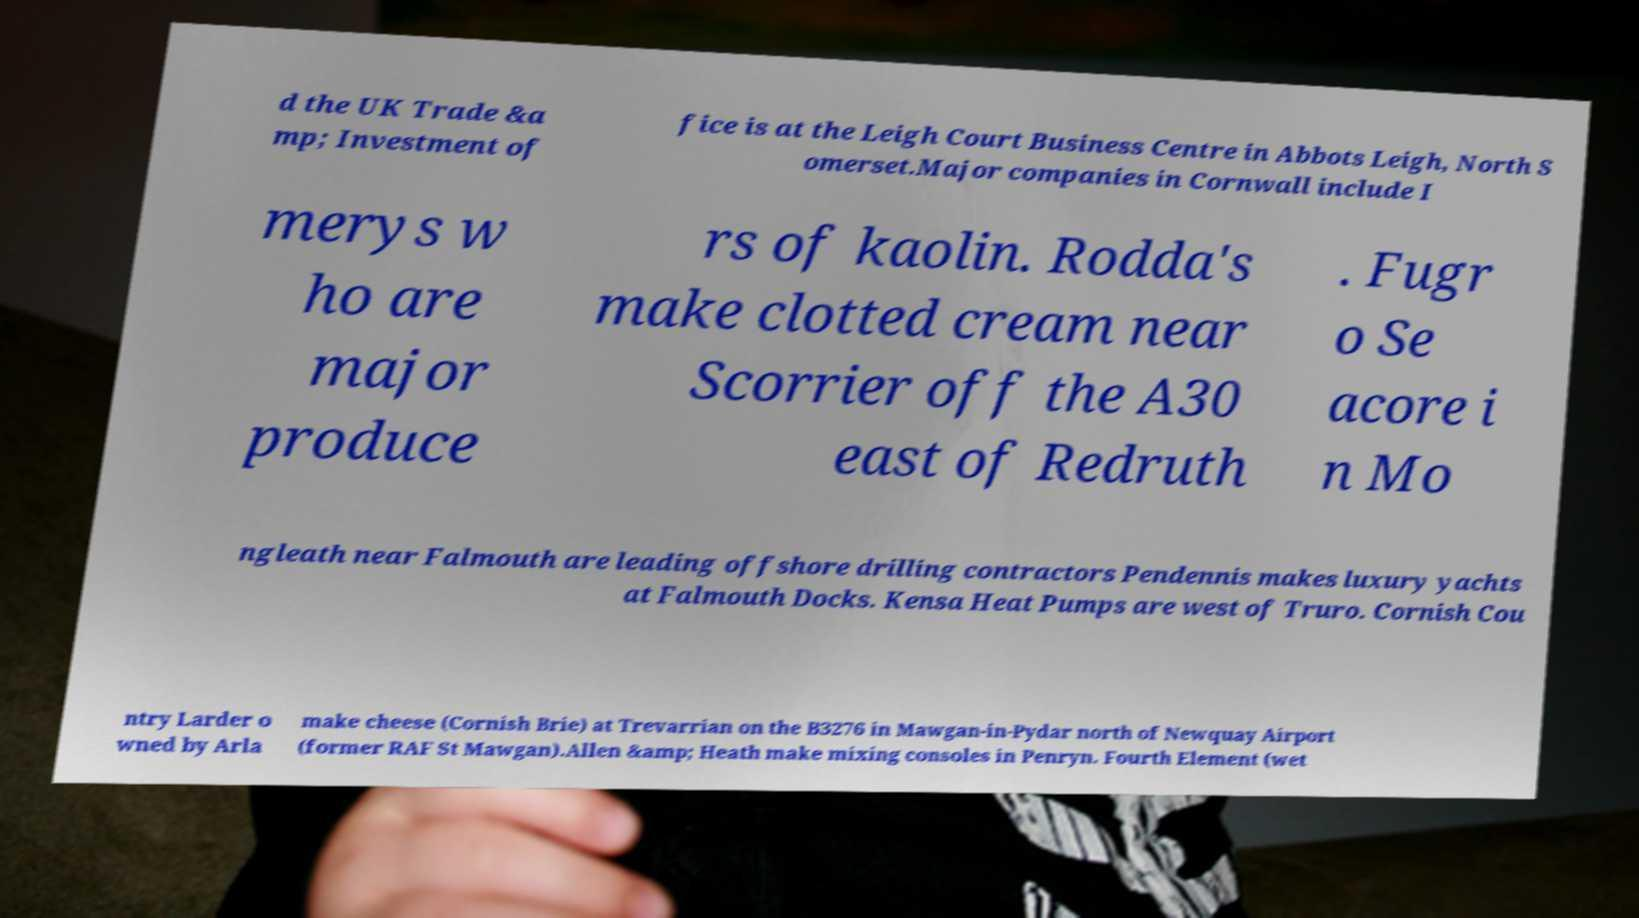There's text embedded in this image that I need extracted. Can you transcribe it verbatim? d the UK Trade &a mp; Investment of fice is at the Leigh Court Business Centre in Abbots Leigh, North S omerset.Major companies in Cornwall include I merys w ho are major produce rs of kaolin. Rodda's make clotted cream near Scorrier off the A30 east of Redruth . Fugr o Se acore i n Mo ngleath near Falmouth are leading offshore drilling contractors Pendennis makes luxury yachts at Falmouth Docks. Kensa Heat Pumps are west of Truro. Cornish Cou ntry Larder o wned by Arla make cheese (Cornish Brie) at Trevarrian on the B3276 in Mawgan-in-Pydar north of Newquay Airport (former RAF St Mawgan).Allen &amp; Heath make mixing consoles in Penryn. Fourth Element (wet 